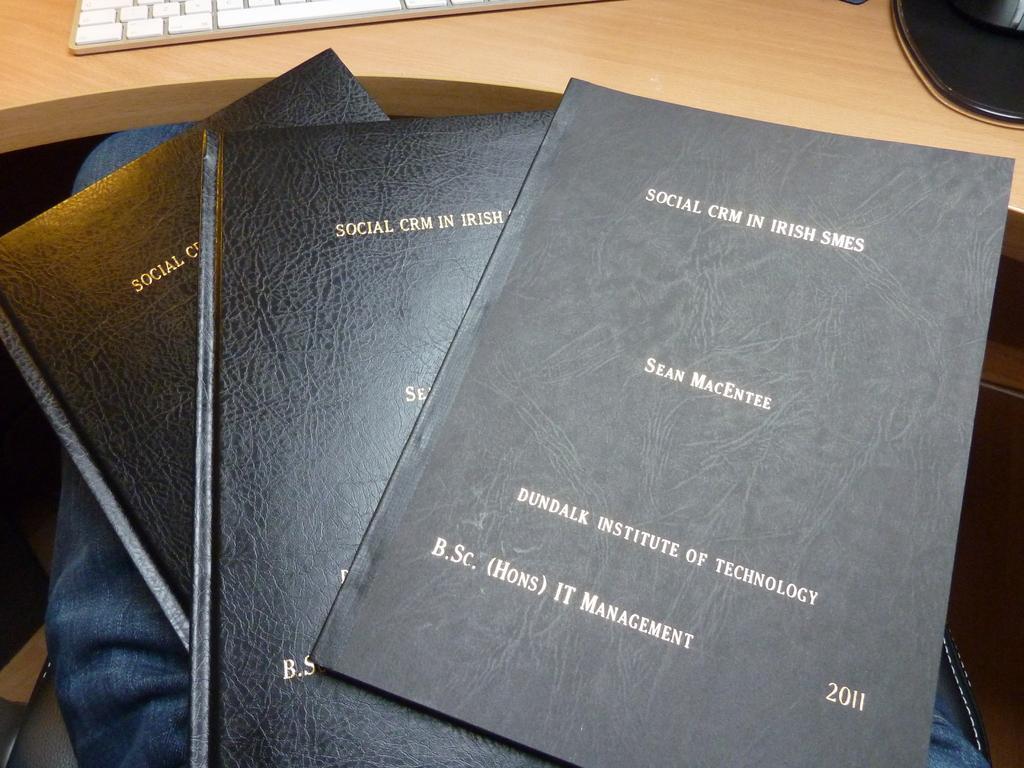Please provide a concise description of this image. In this image I can see few books in black color. I can see the keyboard and few objects on the brown color table. 